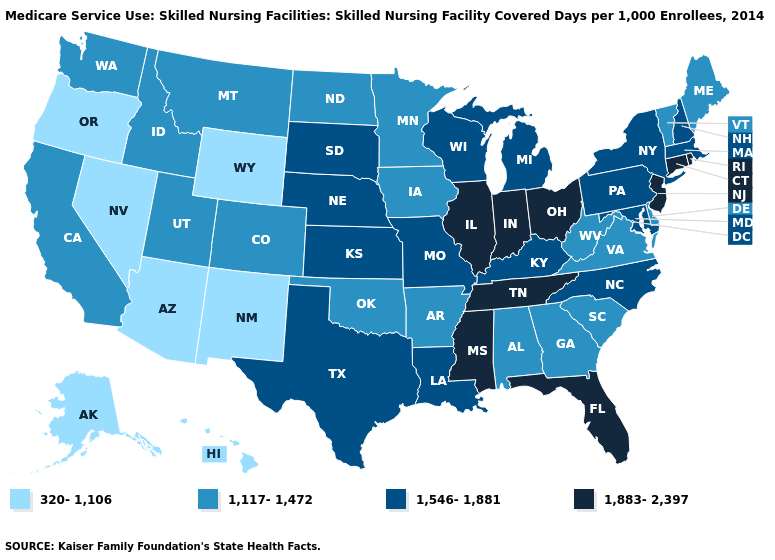What is the value of Missouri?
Short answer required. 1,546-1,881. Does Florida have the lowest value in the USA?
Keep it brief. No. Name the states that have a value in the range 320-1,106?
Quick response, please. Alaska, Arizona, Hawaii, Nevada, New Mexico, Oregon, Wyoming. Name the states that have a value in the range 1,883-2,397?
Concise answer only. Connecticut, Florida, Illinois, Indiana, Mississippi, New Jersey, Ohio, Rhode Island, Tennessee. Name the states that have a value in the range 1,883-2,397?
Quick response, please. Connecticut, Florida, Illinois, Indiana, Mississippi, New Jersey, Ohio, Rhode Island, Tennessee. What is the value of Washington?
Concise answer only. 1,117-1,472. Name the states that have a value in the range 1,883-2,397?
Quick response, please. Connecticut, Florida, Illinois, Indiana, Mississippi, New Jersey, Ohio, Rhode Island, Tennessee. Does the first symbol in the legend represent the smallest category?
Write a very short answer. Yes. Is the legend a continuous bar?
Answer briefly. No. Name the states that have a value in the range 320-1,106?
Quick response, please. Alaska, Arizona, Hawaii, Nevada, New Mexico, Oregon, Wyoming. What is the value of Wisconsin?
Give a very brief answer. 1,546-1,881. Does South Dakota have a higher value than Indiana?
Short answer required. No. What is the highest value in the South ?
Write a very short answer. 1,883-2,397. Name the states that have a value in the range 1,883-2,397?
Answer briefly. Connecticut, Florida, Illinois, Indiana, Mississippi, New Jersey, Ohio, Rhode Island, Tennessee. What is the lowest value in states that border Connecticut?
Write a very short answer. 1,546-1,881. 